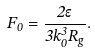Convert formula to latex. <formula><loc_0><loc_0><loc_500><loc_500>F _ { 0 } = \frac { 2 \epsilon } { 3 k _ { 0 } ^ { 3 } R _ { g } } .</formula> 